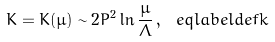Convert formula to latex. <formula><loc_0><loc_0><loc_500><loc_500>K = K ( \mu ) \sim 2 P ^ { 2 } \ln \frac { \mu } { \Lambda } \, , \ e q l a b e l { d e f k }</formula> 